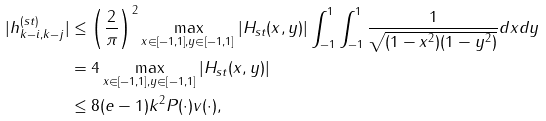Convert formula to latex. <formula><loc_0><loc_0><loc_500><loc_500>| h ^ { ( s t ) } _ { k - i , k - j } | & \leq \left ( \frac { 2 } { \pi } \right ) ^ { 2 } \max _ { x \in [ - 1 , 1 ] , y \in [ - 1 , 1 ] } | H _ { s t } ( x , y ) | \int _ { - 1 } ^ { 1 } \int _ { - 1 } ^ { 1 } \frac { 1 } { \sqrt { ( 1 - x ^ { 2 } ) ( 1 - y ^ { 2 } ) } } d x d y \\ & = 4 \max _ { x \in [ - 1 , 1 ] , y \in [ - 1 , 1 ] } | H _ { s t } ( x , y ) | \\ & \leq 8 ( e - 1 ) k ^ { 2 } \| P ( \cdot ) \| \| v ( \cdot ) \| ,</formula> 